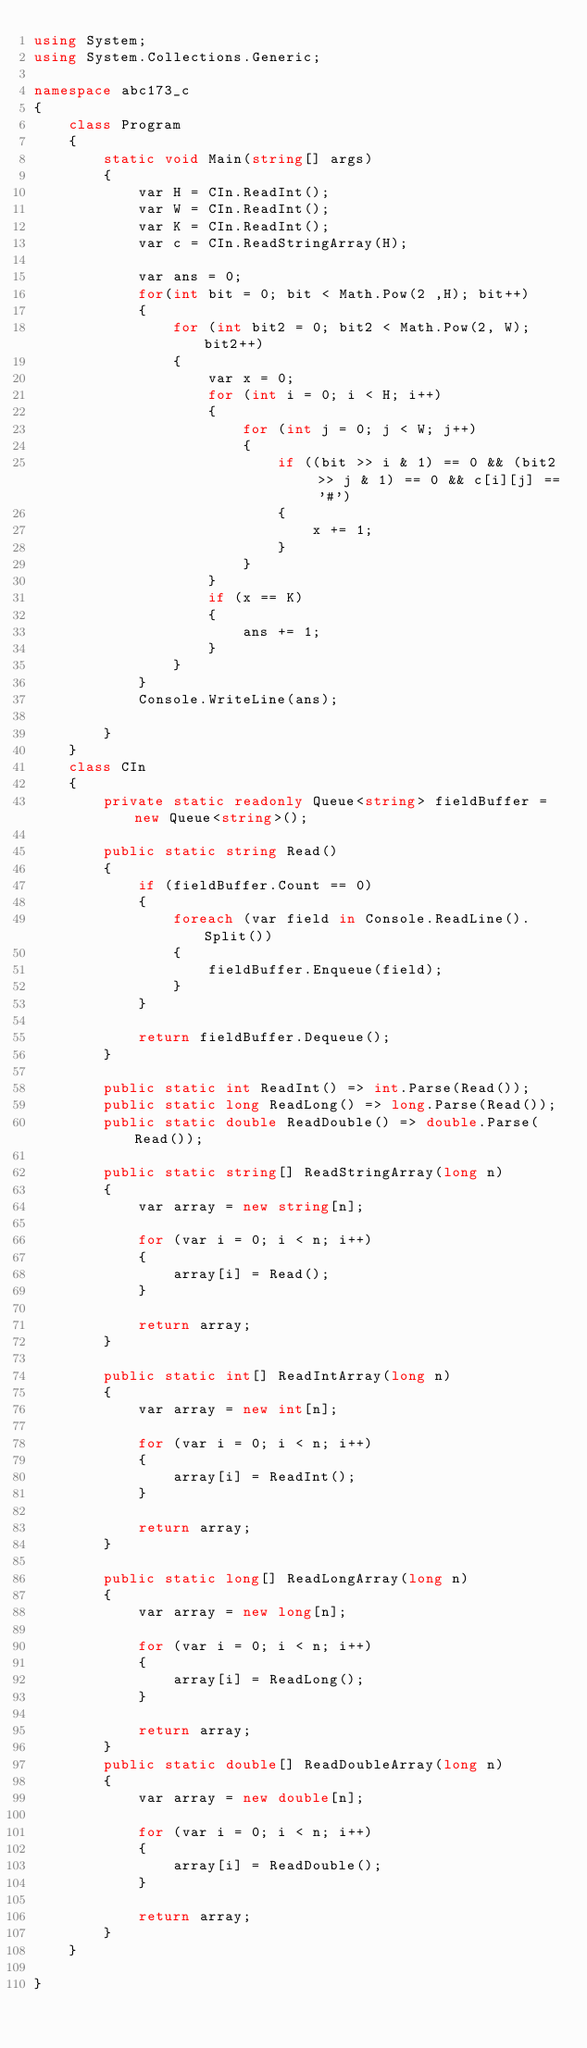Convert code to text. <code><loc_0><loc_0><loc_500><loc_500><_C#_>using System;
using System.Collections.Generic;

namespace abc173_c
{
    class Program
    {
        static void Main(string[] args)
        {
            var H = CIn.ReadInt();
            var W = CIn.ReadInt();
            var K = CIn.ReadInt();
            var c = CIn.ReadStringArray(H);
            
            var ans = 0;
            for(int bit = 0; bit < Math.Pow(2 ,H); bit++)
            {
                for (int bit2 = 0; bit2 < Math.Pow(2, W); bit2++)
                {
                    var x = 0;
                    for (int i = 0; i < H; i++)
                    {
                        for (int j = 0; j < W; j++)
                        {
                            if ((bit >> i & 1) == 0 && (bit2 >> j & 1) == 0 && c[i][j] == '#')
                            {
                                x += 1;
                            }
                        }
                    }
                    if (x == K)
                    {
                        ans += 1;
                    }
                }
            }
            Console.WriteLine(ans);
            
        }
    }
    class CIn
    {
        private static readonly Queue<string> fieldBuffer = new Queue<string>();

        public static string Read()
        {
            if (fieldBuffer.Count == 0)
            {
                foreach (var field in Console.ReadLine().Split())
                {
                    fieldBuffer.Enqueue(field);
                }
            }

            return fieldBuffer.Dequeue();
        }

        public static int ReadInt() => int.Parse(Read());
        public static long ReadLong() => long.Parse(Read());
        public static double ReadDouble() => double.Parse(Read());

        public static string[] ReadStringArray(long n)
        {
            var array = new string[n];

            for (var i = 0; i < n; i++)
            {
                array[i] = Read();
            }

            return array;
        }

        public static int[] ReadIntArray(long n)
        {
            var array = new int[n];

            for (var i = 0; i < n; i++)
            {
                array[i] = ReadInt();
            }

            return array;
        }

        public static long[] ReadLongArray(long n)
        {
            var array = new long[n];

            for (var i = 0; i < n; i++)
            {
                array[i] = ReadLong();
            }

            return array;
        }
        public static double[] ReadDoubleArray(long n)
        {
            var array = new double[n];

            for (var i = 0; i < n; i++)
            {
                array[i] = ReadDouble();
            }

            return array;
        }
    }

}
</code> 